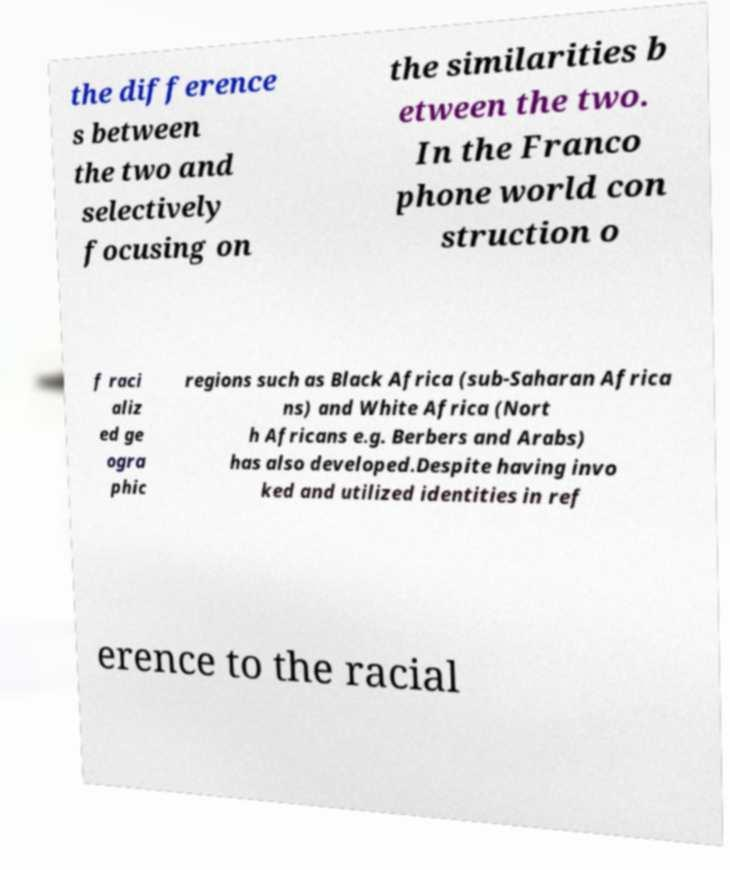Could you assist in decoding the text presented in this image and type it out clearly? the difference s between the two and selectively focusing on the similarities b etween the two. In the Franco phone world con struction o f raci aliz ed ge ogra phic regions such as Black Africa (sub-Saharan Africa ns) and White Africa (Nort h Africans e.g. Berbers and Arabs) has also developed.Despite having invo ked and utilized identities in ref erence to the racial 